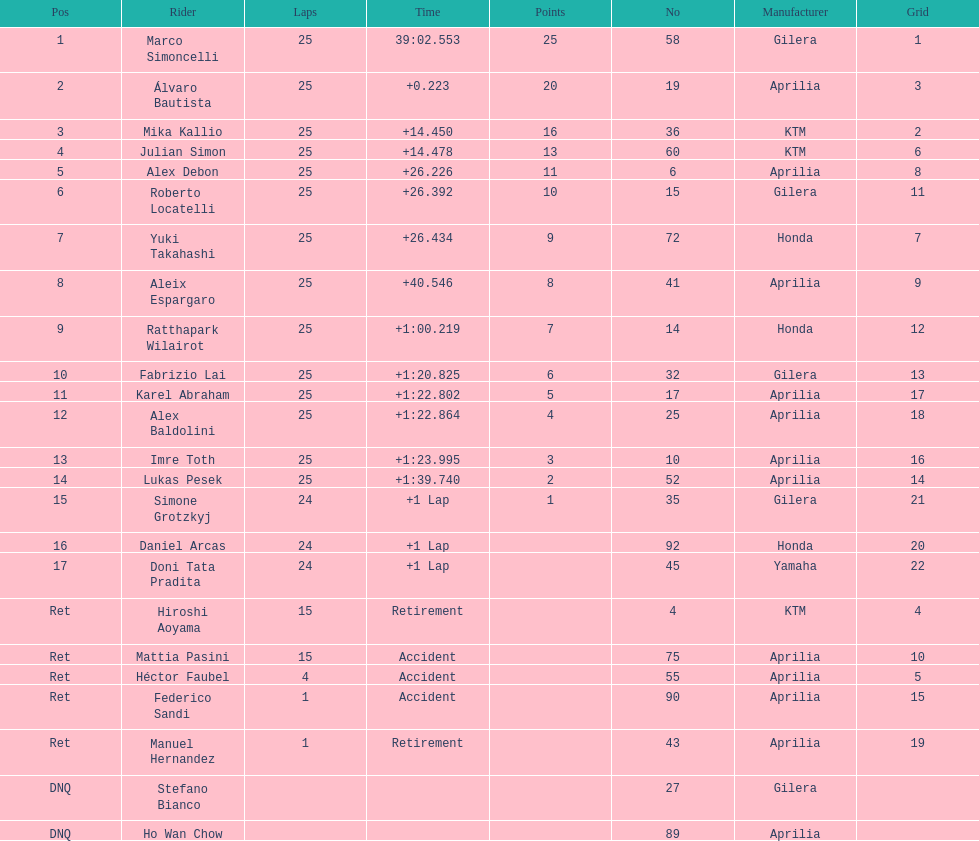The total amount of riders who did not qualify 2. 